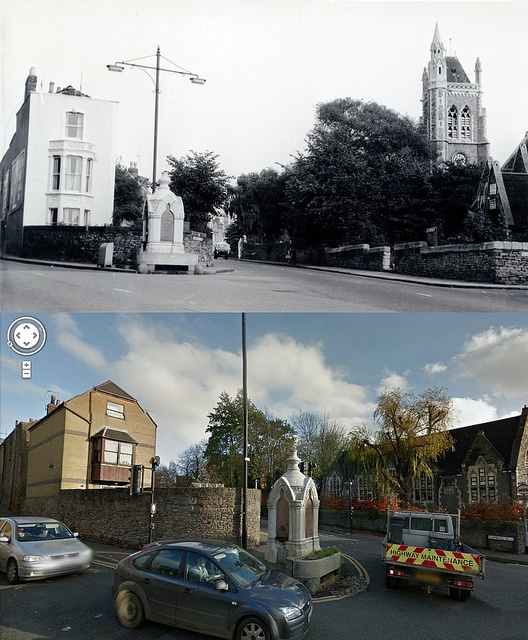Describe the objects in this image and their specific colors. I can see car in white, black, gray, blue, and darkblue tones, truck in white, black, gray, maroon, and olive tones, car in white, gray, darkgray, and black tones, car in white, black, darkgray, gray, and lightgray tones, and truck in white, black, darkgray, gray, and lightgray tones in this image. 